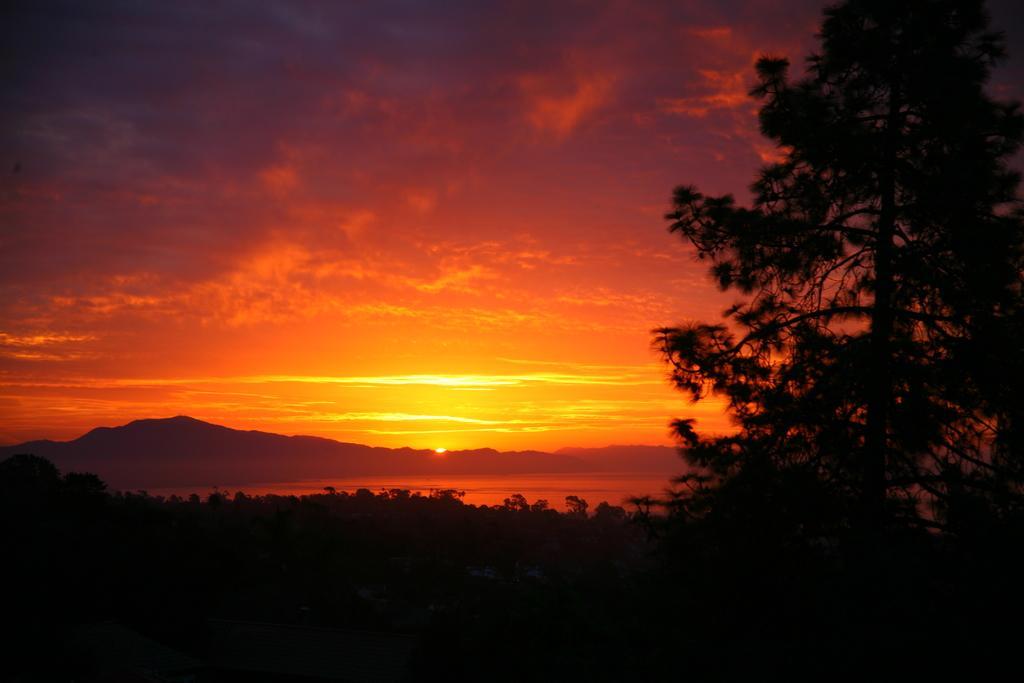Can you describe this image briefly? In this image we can see there are some trees, water and mountains, in the background, we can see the sunlight and the sky with clouds. 